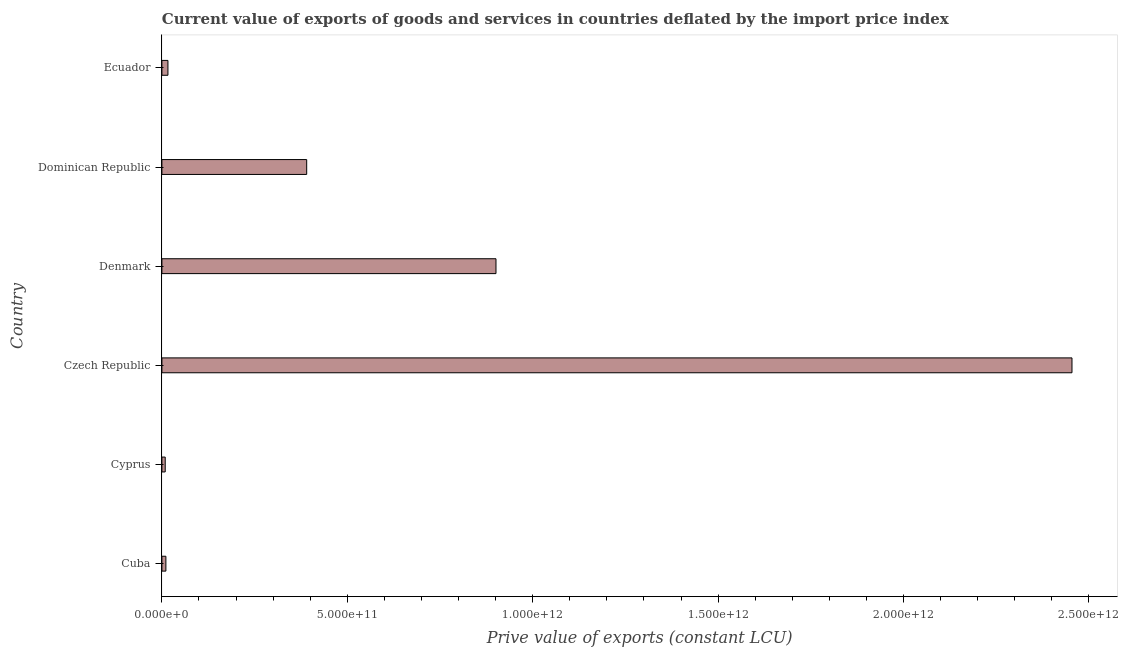What is the title of the graph?
Your answer should be very brief. Current value of exports of goods and services in countries deflated by the import price index. What is the label or title of the X-axis?
Offer a terse response. Prive value of exports (constant LCU). What is the price value of exports in Czech Republic?
Your response must be concise. 2.45e+12. Across all countries, what is the maximum price value of exports?
Provide a short and direct response. 2.45e+12. Across all countries, what is the minimum price value of exports?
Offer a very short reply. 8.93e+09. In which country was the price value of exports maximum?
Offer a terse response. Czech Republic. In which country was the price value of exports minimum?
Ensure brevity in your answer.  Cyprus. What is the sum of the price value of exports?
Give a very brief answer. 3.78e+12. What is the difference between the price value of exports in Czech Republic and Ecuador?
Offer a terse response. 2.44e+12. What is the average price value of exports per country?
Your response must be concise. 6.30e+11. What is the median price value of exports?
Make the answer very short. 2.03e+11. In how many countries, is the price value of exports greater than 2400000000000 LCU?
Your answer should be very brief. 1. What is the ratio of the price value of exports in Denmark to that in Dominican Republic?
Your answer should be compact. 2.31. Is the difference between the price value of exports in Cyprus and Denmark greater than the difference between any two countries?
Make the answer very short. No. What is the difference between the highest and the second highest price value of exports?
Give a very brief answer. 1.55e+12. Is the sum of the price value of exports in Cyprus and Ecuador greater than the maximum price value of exports across all countries?
Your answer should be very brief. No. What is the difference between the highest and the lowest price value of exports?
Your answer should be compact. 2.45e+12. What is the difference between two consecutive major ticks on the X-axis?
Provide a succinct answer. 5.00e+11. Are the values on the major ticks of X-axis written in scientific E-notation?
Your answer should be compact. Yes. What is the Prive value of exports (constant LCU) in Cuba?
Your answer should be very brief. 1.07e+1. What is the Prive value of exports (constant LCU) of Cyprus?
Offer a terse response. 8.93e+09. What is the Prive value of exports (constant LCU) in Czech Republic?
Provide a succinct answer. 2.45e+12. What is the Prive value of exports (constant LCU) in Denmark?
Your answer should be compact. 9.01e+11. What is the Prive value of exports (constant LCU) in Dominican Republic?
Your answer should be compact. 3.90e+11. What is the Prive value of exports (constant LCU) of Ecuador?
Your response must be concise. 1.63e+1. What is the difference between the Prive value of exports (constant LCU) in Cuba and Cyprus?
Your answer should be very brief. 1.81e+09. What is the difference between the Prive value of exports (constant LCU) in Cuba and Czech Republic?
Provide a succinct answer. -2.44e+12. What is the difference between the Prive value of exports (constant LCU) in Cuba and Denmark?
Keep it short and to the point. -8.90e+11. What is the difference between the Prive value of exports (constant LCU) in Cuba and Dominican Republic?
Ensure brevity in your answer.  -3.80e+11. What is the difference between the Prive value of exports (constant LCU) in Cuba and Ecuador?
Ensure brevity in your answer.  -5.54e+09. What is the difference between the Prive value of exports (constant LCU) in Cyprus and Czech Republic?
Provide a short and direct response. -2.45e+12. What is the difference between the Prive value of exports (constant LCU) in Cyprus and Denmark?
Ensure brevity in your answer.  -8.92e+11. What is the difference between the Prive value of exports (constant LCU) in Cyprus and Dominican Republic?
Offer a terse response. -3.82e+11. What is the difference between the Prive value of exports (constant LCU) in Cyprus and Ecuador?
Your answer should be very brief. -7.35e+09. What is the difference between the Prive value of exports (constant LCU) in Czech Republic and Denmark?
Make the answer very short. 1.55e+12. What is the difference between the Prive value of exports (constant LCU) in Czech Republic and Dominican Republic?
Your answer should be very brief. 2.06e+12. What is the difference between the Prive value of exports (constant LCU) in Czech Republic and Ecuador?
Make the answer very short. 2.44e+12. What is the difference between the Prive value of exports (constant LCU) in Denmark and Dominican Republic?
Make the answer very short. 5.11e+11. What is the difference between the Prive value of exports (constant LCU) in Denmark and Ecuador?
Offer a very short reply. 8.85e+11. What is the difference between the Prive value of exports (constant LCU) in Dominican Republic and Ecuador?
Keep it short and to the point. 3.74e+11. What is the ratio of the Prive value of exports (constant LCU) in Cuba to that in Cyprus?
Offer a very short reply. 1.2. What is the ratio of the Prive value of exports (constant LCU) in Cuba to that in Czech Republic?
Your response must be concise. 0. What is the ratio of the Prive value of exports (constant LCU) in Cuba to that in Denmark?
Keep it short and to the point. 0.01. What is the ratio of the Prive value of exports (constant LCU) in Cuba to that in Dominican Republic?
Offer a terse response. 0.03. What is the ratio of the Prive value of exports (constant LCU) in Cuba to that in Ecuador?
Your answer should be very brief. 0.66. What is the ratio of the Prive value of exports (constant LCU) in Cyprus to that in Czech Republic?
Provide a succinct answer. 0. What is the ratio of the Prive value of exports (constant LCU) in Cyprus to that in Dominican Republic?
Give a very brief answer. 0.02. What is the ratio of the Prive value of exports (constant LCU) in Cyprus to that in Ecuador?
Provide a succinct answer. 0.55. What is the ratio of the Prive value of exports (constant LCU) in Czech Republic to that in Denmark?
Your answer should be compact. 2.72. What is the ratio of the Prive value of exports (constant LCU) in Czech Republic to that in Dominican Republic?
Give a very brief answer. 6.29. What is the ratio of the Prive value of exports (constant LCU) in Czech Republic to that in Ecuador?
Your answer should be compact. 150.69. What is the ratio of the Prive value of exports (constant LCU) in Denmark to that in Dominican Republic?
Your response must be concise. 2.31. What is the ratio of the Prive value of exports (constant LCU) in Denmark to that in Ecuador?
Offer a very short reply. 55.32. What is the ratio of the Prive value of exports (constant LCU) in Dominican Republic to that in Ecuador?
Your answer should be compact. 23.97. 